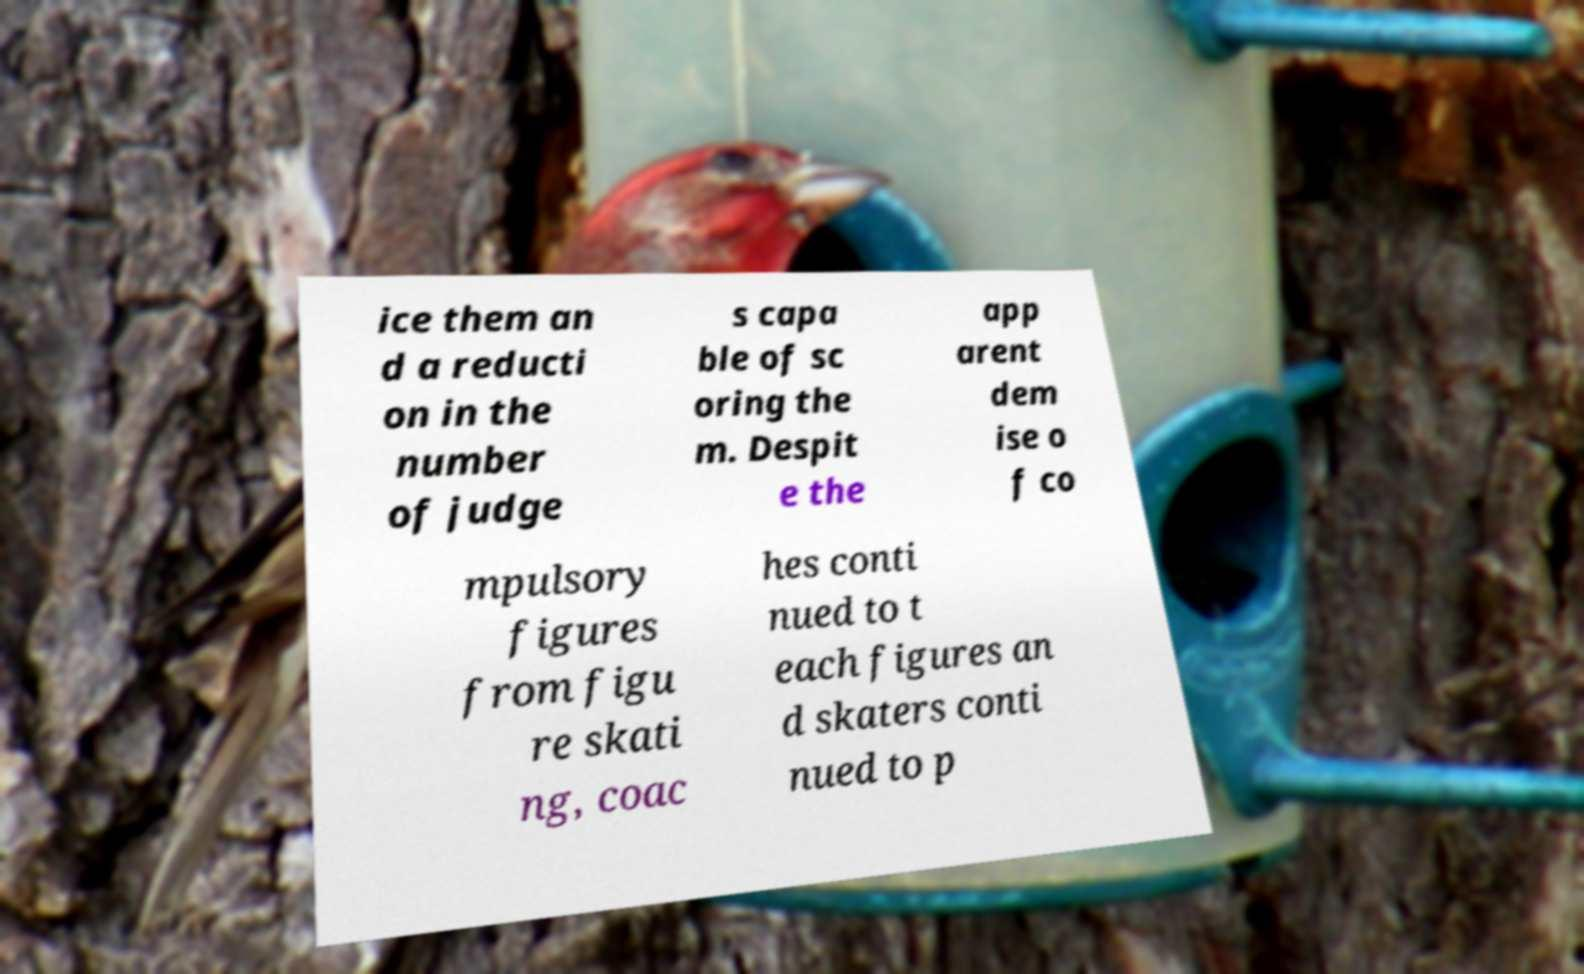Please read and relay the text visible in this image. What does it say? ice them an d a reducti on in the number of judge s capa ble of sc oring the m. Despit e the app arent dem ise o f co mpulsory figures from figu re skati ng, coac hes conti nued to t each figures an d skaters conti nued to p 